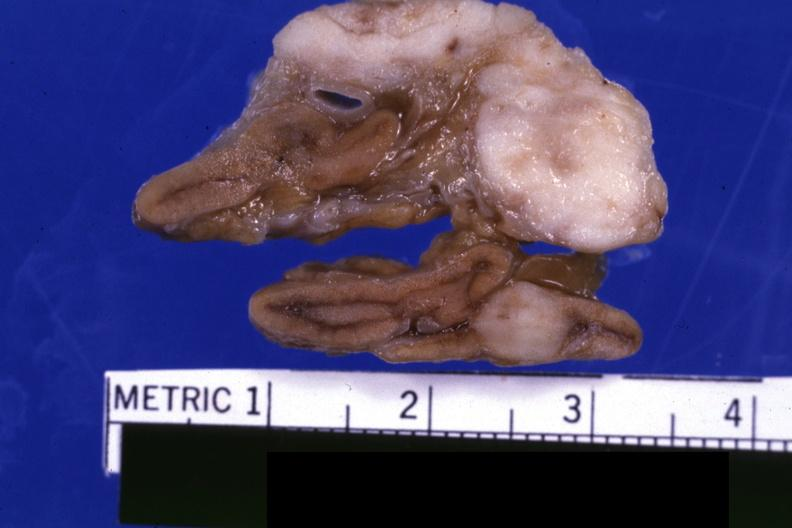s metastatic carcinoma present?
Answer the question using a single word or phrase. Yes 